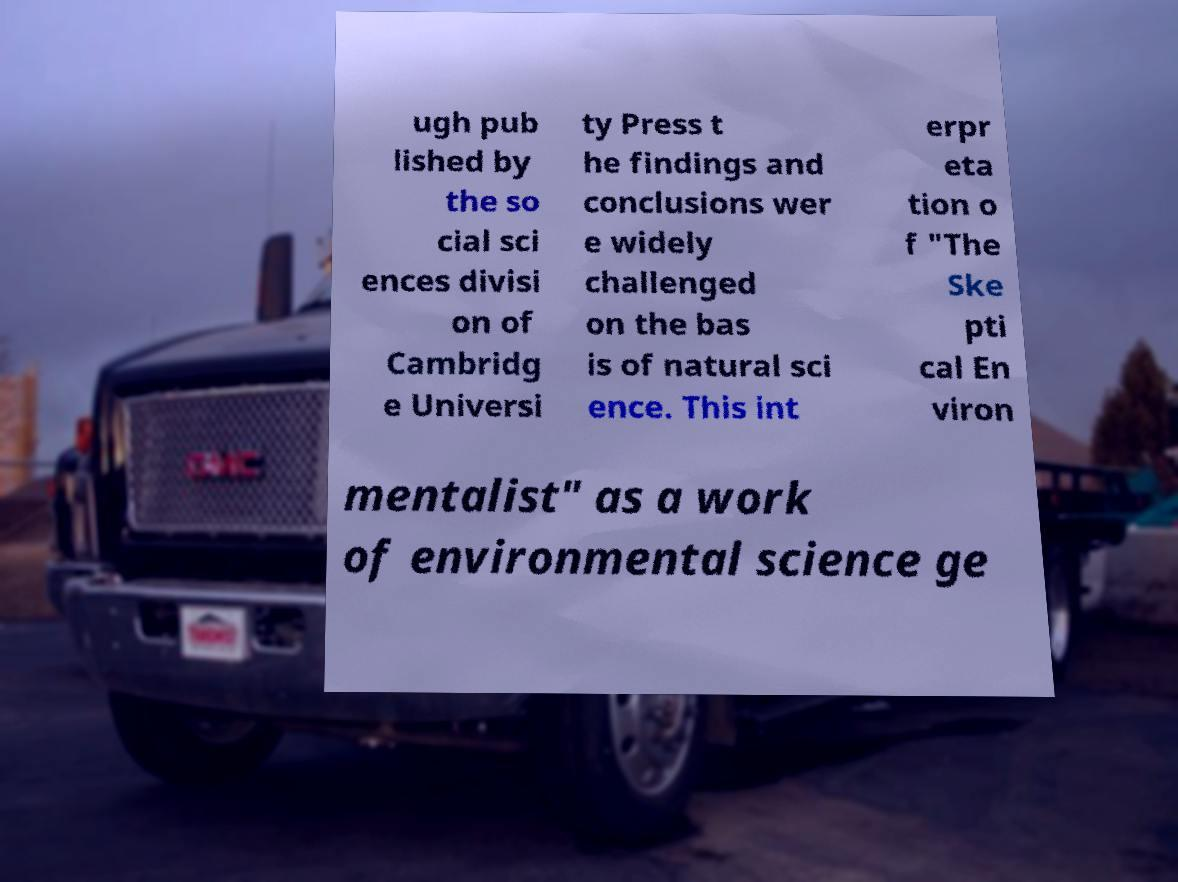Could you extract and type out the text from this image? ugh pub lished by the so cial sci ences divisi on of Cambridg e Universi ty Press t he findings and conclusions wer e widely challenged on the bas is of natural sci ence. This int erpr eta tion o f "The Ske pti cal En viron mentalist" as a work of environmental science ge 